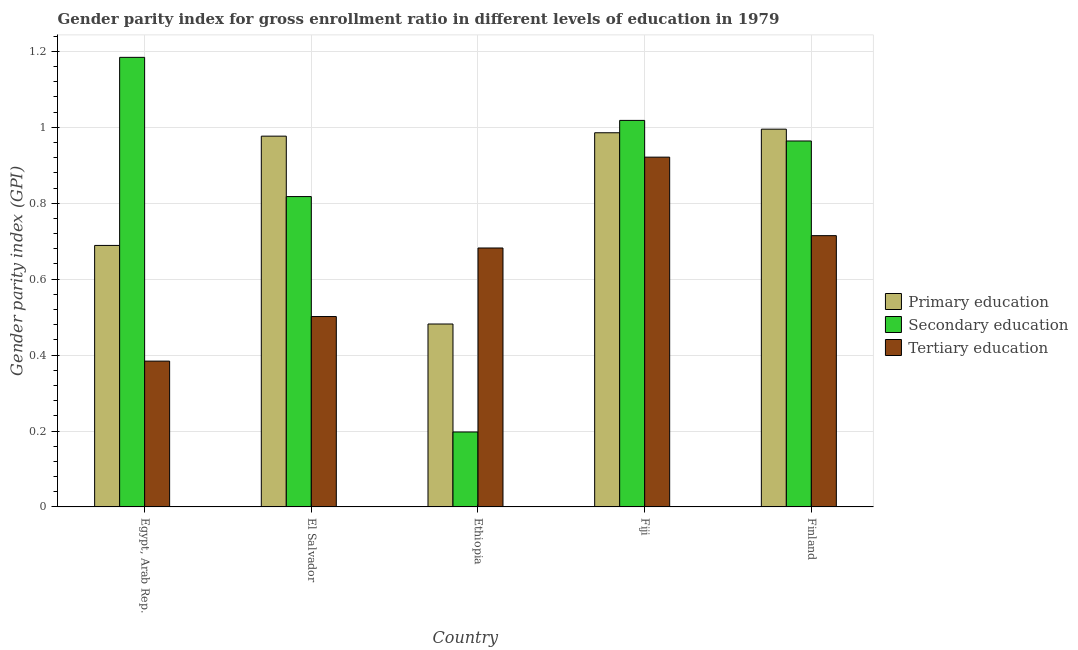How many different coloured bars are there?
Provide a short and direct response. 3. How many bars are there on the 5th tick from the left?
Provide a short and direct response. 3. What is the label of the 4th group of bars from the left?
Your answer should be very brief. Fiji. In how many cases, is the number of bars for a given country not equal to the number of legend labels?
Your answer should be very brief. 0. What is the gender parity index in tertiary education in Fiji?
Give a very brief answer. 0.92. Across all countries, what is the maximum gender parity index in primary education?
Ensure brevity in your answer.  1. Across all countries, what is the minimum gender parity index in primary education?
Provide a short and direct response. 0.48. In which country was the gender parity index in primary education maximum?
Provide a succinct answer. Finland. In which country was the gender parity index in primary education minimum?
Ensure brevity in your answer.  Ethiopia. What is the total gender parity index in secondary education in the graph?
Give a very brief answer. 4.18. What is the difference between the gender parity index in secondary education in El Salvador and that in Fiji?
Give a very brief answer. -0.2. What is the difference between the gender parity index in secondary education in Fiji and the gender parity index in tertiary education in Egypt, Arab Rep.?
Make the answer very short. 0.63. What is the average gender parity index in primary education per country?
Ensure brevity in your answer.  0.83. What is the difference between the gender parity index in primary education and gender parity index in tertiary education in Ethiopia?
Ensure brevity in your answer.  -0.2. What is the ratio of the gender parity index in secondary education in Fiji to that in Finland?
Your answer should be compact. 1.06. What is the difference between the highest and the second highest gender parity index in primary education?
Offer a terse response. 0.01. What is the difference between the highest and the lowest gender parity index in primary education?
Provide a short and direct response. 0.51. Is the sum of the gender parity index in primary education in El Salvador and Ethiopia greater than the maximum gender parity index in secondary education across all countries?
Provide a short and direct response. Yes. What does the 2nd bar from the left in Fiji represents?
Your answer should be very brief. Secondary education. Is it the case that in every country, the sum of the gender parity index in primary education and gender parity index in secondary education is greater than the gender parity index in tertiary education?
Ensure brevity in your answer.  No. How many bars are there?
Your answer should be compact. 15. Are all the bars in the graph horizontal?
Provide a succinct answer. No. How many countries are there in the graph?
Provide a short and direct response. 5. What is the difference between two consecutive major ticks on the Y-axis?
Provide a succinct answer. 0.2. Are the values on the major ticks of Y-axis written in scientific E-notation?
Ensure brevity in your answer.  No. Does the graph contain any zero values?
Your answer should be compact. No. Does the graph contain grids?
Your response must be concise. Yes. What is the title of the graph?
Keep it short and to the point. Gender parity index for gross enrollment ratio in different levels of education in 1979. Does "Refusal of sex" appear as one of the legend labels in the graph?
Give a very brief answer. No. What is the label or title of the X-axis?
Ensure brevity in your answer.  Country. What is the label or title of the Y-axis?
Your response must be concise. Gender parity index (GPI). What is the Gender parity index (GPI) of Primary education in Egypt, Arab Rep.?
Your answer should be very brief. 0.69. What is the Gender parity index (GPI) of Secondary education in Egypt, Arab Rep.?
Your response must be concise. 1.18. What is the Gender parity index (GPI) in Tertiary education in Egypt, Arab Rep.?
Your response must be concise. 0.38. What is the Gender parity index (GPI) of Primary education in El Salvador?
Keep it short and to the point. 0.98. What is the Gender parity index (GPI) of Secondary education in El Salvador?
Make the answer very short. 0.82. What is the Gender parity index (GPI) in Tertiary education in El Salvador?
Your response must be concise. 0.5. What is the Gender parity index (GPI) of Primary education in Ethiopia?
Your response must be concise. 0.48. What is the Gender parity index (GPI) of Secondary education in Ethiopia?
Ensure brevity in your answer.  0.2. What is the Gender parity index (GPI) of Tertiary education in Ethiopia?
Make the answer very short. 0.68. What is the Gender parity index (GPI) of Primary education in Fiji?
Keep it short and to the point. 0.99. What is the Gender parity index (GPI) in Secondary education in Fiji?
Offer a very short reply. 1.02. What is the Gender parity index (GPI) of Tertiary education in Fiji?
Offer a terse response. 0.92. What is the Gender parity index (GPI) of Primary education in Finland?
Make the answer very short. 1. What is the Gender parity index (GPI) in Secondary education in Finland?
Offer a very short reply. 0.96. What is the Gender parity index (GPI) in Tertiary education in Finland?
Your response must be concise. 0.71. Across all countries, what is the maximum Gender parity index (GPI) in Primary education?
Give a very brief answer. 1. Across all countries, what is the maximum Gender parity index (GPI) of Secondary education?
Offer a very short reply. 1.18. Across all countries, what is the maximum Gender parity index (GPI) of Tertiary education?
Provide a succinct answer. 0.92. Across all countries, what is the minimum Gender parity index (GPI) in Primary education?
Offer a terse response. 0.48. Across all countries, what is the minimum Gender parity index (GPI) in Secondary education?
Offer a terse response. 0.2. Across all countries, what is the minimum Gender parity index (GPI) in Tertiary education?
Provide a succinct answer. 0.38. What is the total Gender parity index (GPI) of Primary education in the graph?
Give a very brief answer. 4.13. What is the total Gender parity index (GPI) of Secondary education in the graph?
Give a very brief answer. 4.18. What is the total Gender parity index (GPI) of Tertiary education in the graph?
Provide a succinct answer. 3.2. What is the difference between the Gender parity index (GPI) of Primary education in Egypt, Arab Rep. and that in El Salvador?
Ensure brevity in your answer.  -0.29. What is the difference between the Gender parity index (GPI) in Secondary education in Egypt, Arab Rep. and that in El Salvador?
Ensure brevity in your answer.  0.37. What is the difference between the Gender parity index (GPI) in Tertiary education in Egypt, Arab Rep. and that in El Salvador?
Ensure brevity in your answer.  -0.12. What is the difference between the Gender parity index (GPI) in Primary education in Egypt, Arab Rep. and that in Ethiopia?
Make the answer very short. 0.21. What is the difference between the Gender parity index (GPI) in Secondary education in Egypt, Arab Rep. and that in Ethiopia?
Make the answer very short. 0.99. What is the difference between the Gender parity index (GPI) in Tertiary education in Egypt, Arab Rep. and that in Ethiopia?
Keep it short and to the point. -0.3. What is the difference between the Gender parity index (GPI) of Primary education in Egypt, Arab Rep. and that in Fiji?
Your response must be concise. -0.3. What is the difference between the Gender parity index (GPI) in Secondary education in Egypt, Arab Rep. and that in Fiji?
Ensure brevity in your answer.  0.17. What is the difference between the Gender parity index (GPI) of Tertiary education in Egypt, Arab Rep. and that in Fiji?
Provide a short and direct response. -0.54. What is the difference between the Gender parity index (GPI) in Primary education in Egypt, Arab Rep. and that in Finland?
Make the answer very short. -0.31. What is the difference between the Gender parity index (GPI) of Secondary education in Egypt, Arab Rep. and that in Finland?
Your answer should be very brief. 0.22. What is the difference between the Gender parity index (GPI) in Tertiary education in Egypt, Arab Rep. and that in Finland?
Keep it short and to the point. -0.33. What is the difference between the Gender parity index (GPI) of Primary education in El Salvador and that in Ethiopia?
Provide a short and direct response. 0.49. What is the difference between the Gender parity index (GPI) in Secondary education in El Salvador and that in Ethiopia?
Offer a very short reply. 0.62. What is the difference between the Gender parity index (GPI) of Tertiary education in El Salvador and that in Ethiopia?
Provide a succinct answer. -0.18. What is the difference between the Gender parity index (GPI) of Primary education in El Salvador and that in Fiji?
Your response must be concise. -0.01. What is the difference between the Gender parity index (GPI) in Secondary education in El Salvador and that in Fiji?
Your answer should be very brief. -0.2. What is the difference between the Gender parity index (GPI) of Tertiary education in El Salvador and that in Fiji?
Your response must be concise. -0.42. What is the difference between the Gender parity index (GPI) of Primary education in El Salvador and that in Finland?
Ensure brevity in your answer.  -0.02. What is the difference between the Gender parity index (GPI) in Secondary education in El Salvador and that in Finland?
Your response must be concise. -0.15. What is the difference between the Gender parity index (GPI) of Tertiary education in El Salvador and that in Finland?
Ensure brevity in your answer.  -0.21. What is the difference between the Gender parity index (GPI) of Primary education in Ethiopia and that in Fiji?
Ensure brevity in your answer.  -0.5. What is the difference between the Gender parity index (GPI) in Secondary education in Ethiopia and that in Fiji?
Your response must be concise. -0.82. What is the difference between the Gender parity index (GPI) in Tertiary education in Ethiopia and that in Fiji?
Make the answer very short. -0.24. What is the difference between the Gender parity index (GPI) of Primary education in Ethiopia and that in Finland?
Make the answer very short. -0.51. What is the difference between the Gender parity index (GPI) of Secondary education in Ethiopia and that in Finland?
Keep it short and to the point. -0.77. What is the difference between the Gender parity index (GPI) in Tertiary education in Ethiopia and that in Finland?
Keep it short and to the point. -0.03. What is the difference between the Gender parity index (GPI) in Primary education in Fiji and that in Finland?
Offer a terse response. -0.01. What is the difference between the Gender parity index (GPI) of Secondary education in Fiji and that in Finland?
Provide a short and direct response. 0.05. What is the difference between the Gender parity index (GPI) of Tertiary education in Fiji and that in Finland?
Give a very brief answer. 0.21. What is the difference between the Gender parity index (GPI) in Primary education in Egypt, Arab Rep. and the Gender parity index (GPI) in Secondary education in El Salvador?
Give a very brief answer. -0.13. What is the difference between the Gender parity index (GPI) of Primary education in Egypt, Arab Rep. and the Gender parity index (GPI) of Tertiary education in El Salvador?
Give a very brief answer. 0.19. What is the difference between the Gender parity index (GPI) in Secondary education in Egypt, Arab Rep. and the Gender parity index (GPI) in Tertiary education in El Salvador?
Offer a terse response. 0.68. What is the difference between the Gender parity index (GPI) in Primary education in Egypt, Arab Rep. and the Gender parity index (GPI) in Secondary education in Ethiopia?
Your answer should be compact. 0.49. What is the difference between the Gender parity index (GPI) in Primary education in Egypt, Arab Rep. and the Gender parity index (GPI) in Tertiary education in Ethiopia?
Your response must be concise. 0.01. What is the difference between the Gender parity index (GPI) of Secondary education in Egypt, Arab Rep. and the Gender parity index (GPI) of Tertiary education in Ethiopia?
Give a very brief answer. 0.5. What is the difference between the Gender parity index (GPI) in Primary education in Egypt, Arab Rep. and the Gender parity index (GPI) in Secondary education in Fiji?
Offer a very short reply. -0.33. What is the difference between the Gender parity index (GPI) in Primary education in Egypt, Arab Rep. and the Gender parity index (GPI) in Tertiary education in Fiji?
Your answer should be very brief. -0.23. What is the difference between the Gender parity index (GPI) of Secondary education in Egypt, Arab Rep. and the Gender parity index (GPI) of Tertiary education in Fiji?
Your response must be concise. 0.26. What is the difference between the Gender parity index (GPI) in Primary education in Egypt, Arab Rep. and the Gender parity index (GPI) in Secondary education in Finland?
Give a very brief answer. -0.28. What is the difference between the Gender parity index (GPI) of Primary education in Egypt, Arab Rep. and the Gender parity index (GPI) of Tertiary education in Finland?
Offer a terse response. -0.03. What is the difference between the Gender parity index (GPI) in Secondary education in Egypt, Arab Rep. and the Gender parity index (GPI) in Tertiary education in Finland?
Make the answer very short. 0.47. What is the difference between the Gender parity index (GPI) in Primary education in El Salvador and the Gender parity index (GPI) in Secondary education in Ethiopia?
Offer a terse response. 0.78. What is the difference between the Gender parity index (GPI) of Primary education in El Salvador and the Gender parity index (GPI) of Tertiary education in Ethiopia?
Make the answer very short. 0.29. What is the difference between the Gender parity index (GPI) of Secondary education in El Salvador and the Gender parity index (GPI) of Tertiary education in Ethiopia?
Keep it short and to the point. 0.14. What is the difference between the Gender parity index (GPI) of Primary education in El Salvador and the Gender parity index (GPI) of Secondary education in Fiji?
Provide a short and direct response. -0.04. What is the difference between the Gender parity index (GPI) in Primary education in El Salvador and the Gender parity index (GPI) in Tertiary education in Fiji?
Give a very brief answer. 0.06. What is the difference between the Gender parity index (GPI) in Secondary education in El Salvador and the Gender parity index (GPI) in Tertiary education in Fiji?
Keep it short and to the point. -0.1. What is the difference between the Gender parity index (GPI) in Primary education in El Salvador and the Gender parity index (GPI) in Secondary education in Finland?
Provide a short and direct response. 0.01. What is the difference between the Gender parity index (GPI) of Primary education in El Salvador and the Gender parity index (GPI) of Tertiary education in Finland?
Give a very brief answer. 0.26. What is the difference between the Gender parity index (GPI) in Secondary education in El Salvador and the Gender parity index (GPI) in Tertiary education in Finland?
Your answer should be compact. 0.1. What is the difference between the Gender parity index (GPI) of Primary education in Ethiopia and the Gender parity index (GPI) of Secondary education in Fiji?
Provide a short and direct response. -0.54. What is the difference between the Gender parity index (GPI) of Primary education in Ethiopia and the Gender parity index (GPI) of Tertiary education in Fiji?
Give a very brief answer. -0.44. What is the difference between the Gender parity index (GPI) in Secondary education in Ethiopia and the Gender parity index (GPI) in Tertiary education in Fiji?
Offer a very short reply. -0.72. What is the difference between the Gender parity index (GPI) of Primary education in Ethiopia and the Gender parity index (GPI) of Secondary education in Finland?
Offer a very short reply. -0.48. What is the difference between the Gender parity index (GPI) in Primary education in Ethiopia and the Gender parity index (GPI) in Tertiary education in Finland?
Offer a very short reply. -0.23. What is the difference between the Gender parity index (GPI) of Secondary education in Ethiopia and the Gender parity index (GPI) of Tertiary education in Finland?
Make the answer very short. -0.52. What is the difference between the Gender parity index (GPI) in Primary education in Fiji and the Gender parity index (GPI) in Secondary education in Finland?
Your answer should be very brief. 0.02. What is the difference between the Gender parity index (GPI) in Primary education in Fiji and the Gender parity index (GPI) in Tertiary education in Finland?
Offer a terse response. 0.27. What is the difference between the Gender parity index (GPI) in Secondary education in Fiji and the Gender parity index (GPI) in Tertiary education in Finland?
Make the answer very short. 0.3. What is the average Gender parity index (GPI) of Primary education per country?
Provide a succinct answer. 0.83. What is the average Gender parity index (GPI) of Secondary education per country?
Make the answer very short. 0.84. What is the average Gender parity index (GPI) in Tertiary education per country?
Keep it short and to the point. 0.64. What is the difference between the Gender parity index (GPI) of Primary education and Gender parity index (GPI) of Secondary education in Egypt, Arab Rep.?
Your response must be concise. -0.5. What is the difference between the Gender parity index (GPI) in Primary education and Gender parity index (GPI) in Tertiary education in Egypt, Arab Rep.?
Offer a very short reply. 0.3. What is the difference between the Gender parity index (GPI) of Secondary education and Gender parity index (GPI) of Tertiary education in Egypt, Arab Rep.?
Provide a short and direct response. 0.8. What is the difference between the Gender parity index (GPI) in Primary education and Gender parity index (GPI) in Secondary education in El Salvador?
Your answer should be compact. 0.16. What is the difference between the Gender parity index (GPI) in Primary education and Gender parity index (GPI) in Tertiary education in El Salvador?
Make the answer very short. 0.48. What is the difference between the Gender parity index (GPI) in Secondary education and Gender parity index (GPI) in Tertiary education in El Salvador?
Give a very brief answer. 0.32. What is the difference between the Gender parity index (GPI) in Primary education and Gender parity index (GPI) in Secondary education in Ethiopia?
Give a very brief answer. 0.28. What is the difference between the Gender parity index (GPI) of Primary education and Gender parity index (GPI) of Tertiary education in Ethiopia?
Provide a succinct answer. -0.2. What is the difference between the Gender parity index (GPI) in Secondary education and Gender parity index (GPI) in Tertiary education in Ethiopia?
Keep it short and to the point. -0.48. What is the difference between the Gender parity index (GPI) of Primary education and Gender parity index (GPI) of Secondary education in Fiji?
Your answer should be very brief. -0.03. What is the difference between the Gender parity index (GPI) of Primary education and Gender parity index (GPI) of Tertiary education in Fiji?
Make the answer very short. 0.06. What is the difference between the Gender parity index (GPI) in Secondary education and Gender parity index (GPI) in Tertiary education in Fiji?
Make the answer very short. 0.1. What is the difference between the Gender parity index (GPI) in Primary education and Gender parity index (GPI) in Secondary education in Finland?
Offer a very short reply. 0.03. What is the difference between the Gender parity index (GPI) of Primary education and Gender parity index (GPI) of Tertiary education in Finland?
Your answer should be very brief. 0.28. What is the difference between the Gender parity index (GPI) in Secondary education and Gender parity index (GPI) in Tertiary education in Finland?
Your response must be concise. 0.25. What is the ratio of the Gender parity index (GPI) of Primary education in Egypt, Arab Rep. to that in El Salvador?
Offer a very short reply. 0.71. What is the ratio of the Gender parity index (GPI) in Secondary education in Egypt, Arab Rep. to that in El Salvador?
Make the answer very short. 1.45. What is the ratio of the Gender parity index (GPI) in Tertiary education in Egypt, Arab Rep. to that in El Salvador?
Your answer should be very brief. 0.77. What is the ratio of the Gender parity index (GPI) of Primary education in Egypt, Arab Rep. to that in Ethiopia?
Ensure brevity in your answer.  1.43. What is the ratio of the Gender parity index (GPI) in Secondary education in Egypt, Arab Rep. to that in Ethiopia?
Make the answer very short. 6. What is the ratio of the Gender parity index (GPI) in Tertiary education in Egypt, Arab Rep. to that in Ethiopia?
Ensure brevity in your answer.  0.56. What is the ratio of the Gender parity index (GPI) in Primary education in Egypt, Arab Rep. to that in Fiji?
Offer a terse response. 0.7. What is the ratio of the Gender parity index (GPI) in Secondary education in Egypt, Arab Rep. to that in Fiji?
Offer a very short reply. 1.16. What is the ratio of the Gender parity index (GPI) of Tertiary education in Egypt, Arab Rep. to that in Fiji?
Your answer should be very brief. 0.42. What is the ratio of the Gender parity index (GPI) in Primary education in Egypt, Arab Rep. to that in Finland?
Your answer should be compact. 0.69. What is the ratio of the Gender parity index (GPI) of Secondary education in Egypt, Arab Rep. to that in Finland?
Provide a succinct answer. 1.23. What is the ratio of the Gender parity index (GPI) in Tertiary education in Egypt, Arab Rep. to that in Finland?
Provide a short and direct response. 0.54. What is the ratio of the Gender parity index (GPI) in Primary education in El Salvador to that in Ethiopia?
Your response must be concise. 2.03. What is the ratio of the Gender parity index (GPI) in Secondary education in El Salvador to that in Ethiopia?
Keep it short and to the point. 4.14. What is the ratio of the Gender parity index (GPI) in Tertiary education in El Salvador to that in Ethiopia?
Your response must be concise. 0.74. What is the ratio of the Gender parity index (GPI) in Secondary education in El Salvador to that in Fiji?
Offer a very short reply. 0.8. What is the ratio of the Gender parity index (GPI) in Tertiary education in El Salvador to that in Fiji?
Ensure brevity in your answer.  0.54. What is the ratio of the Gender parity index (GPI) of Primary education in El Salvador to that in Finland?
Give a very brief answer. 0.98. What is the ratio of the Gender parity index (GPI) of Secondary education in El Salvador to that in Finland?
Make the answer very short. 0.85. What is the ratio of the Gender parity index (GPI) in Tertiary education in El Salvador to that in Finland?
Your answer should be compact. 0.7. What is the ratio of the Gender parity index (GPI) of Primary education in Ethiopia to that in Fiji?
Provide a succinct answer. 0.49. What is the ratio of the Gender parity index (GPI) in Secondary education in Ethiopia to that in Fiji?
Give a very brief answer. 0.19. What is the ratio of the Gender parity index (GPI) in Tertiary education in Ethiopia to that in Fiji?
Your answer should be very brief. 0.74. What is the ratio of the Gender parity index (GPI) in Primary education in Ethiopia to that in Finland?
Offer a terse response. 0.48. What is the ratio of the Gender parity index (GPI) of Secondary education in Ethiopia to that in Finland?
Your answer should be compact. 0.2. What is the ratio of the Gender parity index (GPI) in Tertiary education in Ethiopia to that in Finland?
Offer a very short reply. 0.95. What is the ratio of the Gender parity index (GPI) in Secondary education in Fiji to that in Finland?
Give a very brief answer. 1.06. What is the ratio of the Gender parity index (GPI) in Tertiary education in Fiji to that in Finland?
Ensure brevity in your answer.  1.29. What is the difference between the highest and the second highest Gender parity index (GPI) of Primary education?
Offer a very short reply. 0.01. What is the difference between the highest and the second highest Gender parity index (GPI) in Secondary education?
Provide a short and direct response. 0.17. What is the difference between the highest and the second highest Gender parity index (GPI) of Tertiary education?
Your answer should be very brief. 0.21. What is the difference between the highest and the lowest Gender parity index (GPI) in Primary education?
Ensure brevity in your answer.  0.51. What is the difference between the highest and the lowest Gender parity index (GPI) of Secondary education?
Offer a very short reply. 0.99. What is the difference between the highest and the lowest Gender parity index (GPI) of Tertiary education?
Make the answer very short. 0.54. 